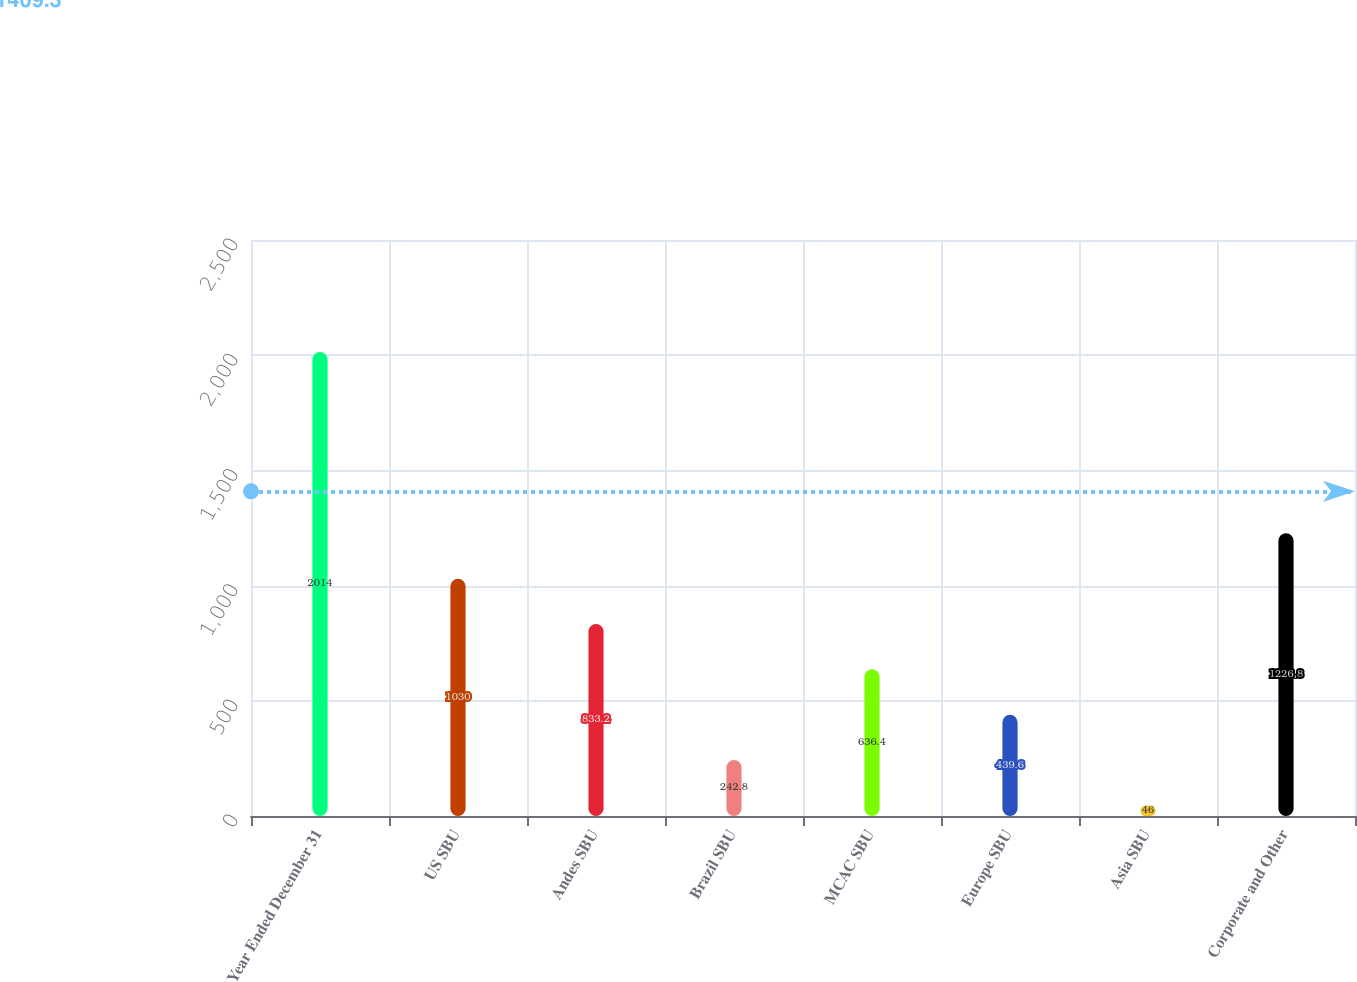Convert chart. <chart><loc_0><loc_0><loc_500><loc_500><bar_chart><fcel>Year Ended December 31<fcel>US SBU<fcel>Andes SBU<fcel>Brazil SBU<fcel>MCAC SBU<fcel>Europe SBU<fcel>Asia SBU<fcel>Corporate and Other<nl><fcel>2014<fcel>1030<fcel>833.2<fcel>242.8<fcel>636.4<fcel>439.6<fcel>46<fcel>1226.8<nl></chart> 